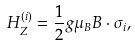Convert formula to latex. <formula><loc_0><loc_0><loc_500><loc_500>H _ { Z } ^ { \left ( i \right ) } = \frac { 1 } { 2 } g \mu _ { B } B \cdot \sigma _ { i } ,</formula> 